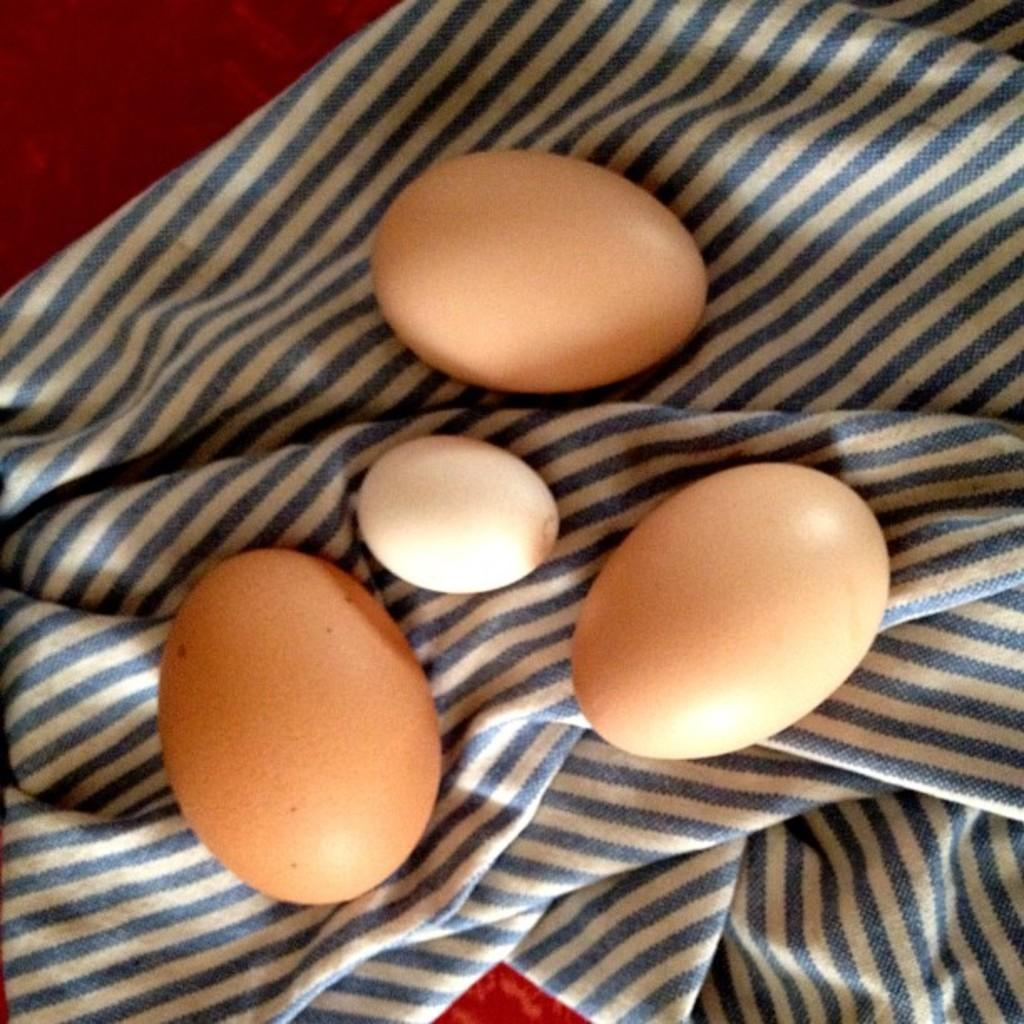How many eggs are visible in the image? There are four eggs in the image. What is the eggs placed on? The eggs are kept on a cloth. What type of lettuce is being used as a cushion for the eggs in the image? There is no lettuce present in the image; the eggs are kept on a cloth. What type of vehicle can be seen in the image? There is no vehicle present in the image; it only features four eggs on a cloth. 